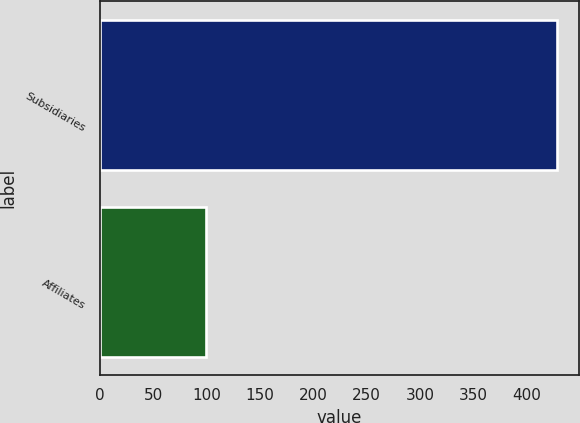Convert chart to OTSL. <chart><loc_0><loc_0><loc_500><loc_500><bar_chart><fcel>Subsidiaries<fcel>Affiliates<nl><fcel>428<fcel>100<nl></chart> 